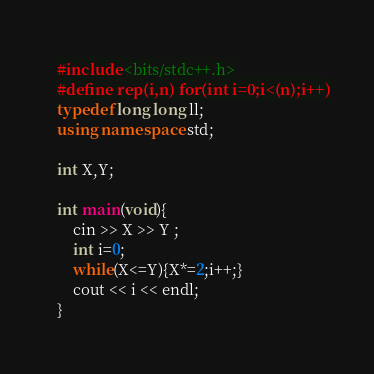Convert code to text. <code><loc_0><loc_0><loc_500><loc_500><_C++_>#include <bits/stdc++.h>
#define rep(i,n) for(int i=0;i<(n);i++)
typedef long long ll;
using namespace std;

int X,Y;

int main(void){
    cin >> X >> Y ;
    int i=0;
    while(X<=Y){X*=2;i++;}
    cout << i << endl;
}
</code> 